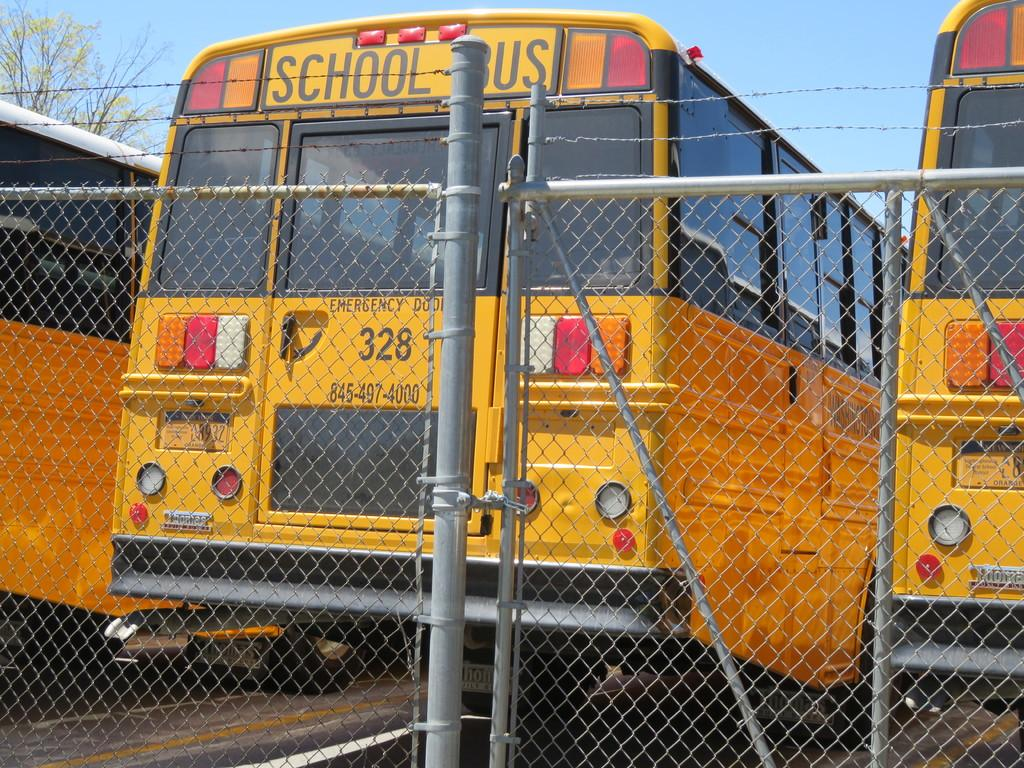How many buses are visible in the image? There are three buses in the image. What color are the buses? The buses are yellow in color. What is located behind the buses in the image? There is a fencing behind the buses. What type of knee injury can be seen on the bus in the image? There is no knee injury present in the image; it features three yellow buses and a fencing behind them. 